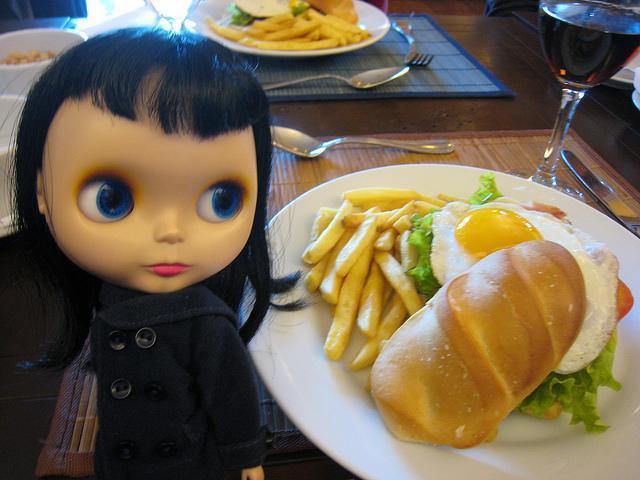How many spoons can you see?
Give a very brief answer. 1. How many bowls are there?
Give a very brief answer. 2. How many umbrellas are shown?
Give a very brief answer. 0. 